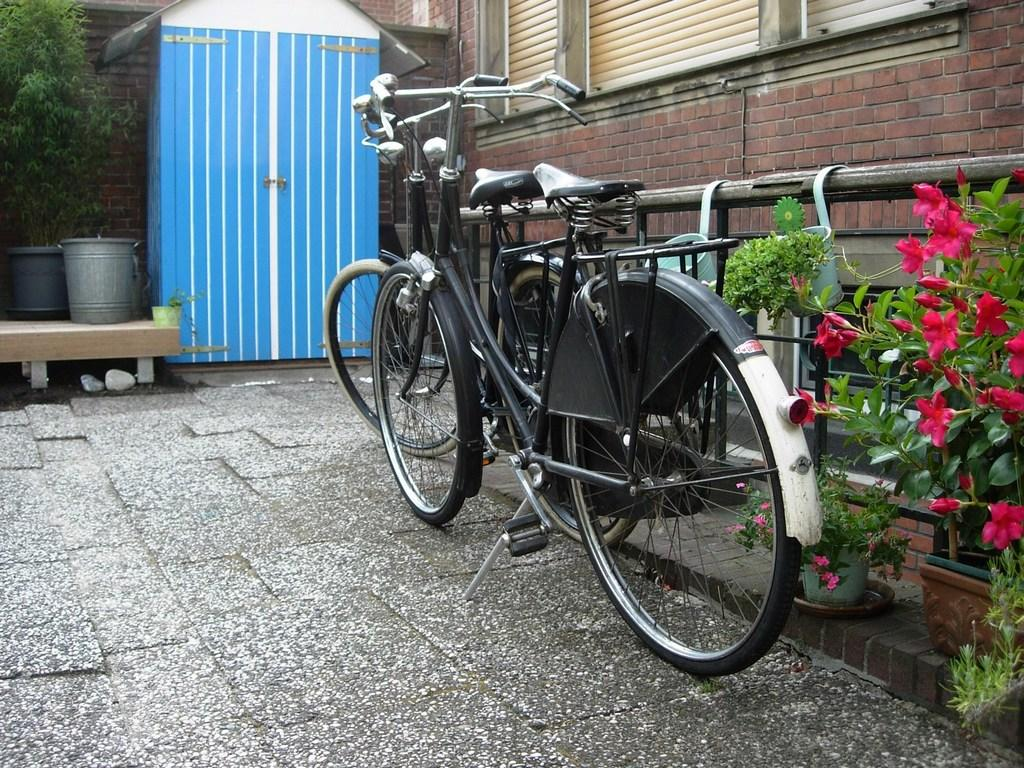What can be seen on the ground in the image? There are bicycles on the ground in the image. What type of plants are present in the image? There are house plants with flowers in the image. What is the background of the image made of? There is a wall in the image. Is there any opening in the wall? Yes, there is a window in the image. What type of structure is visible in the image? There is a shed in the image. What other natural element is present in the image? There is a tree in the image. Can you describe any other objects in the image? There are some unspecified objects in the image. What type of bird is perched on the wren in the image? There is no wren present in the image. What type of badge is being worn by the person in the image? There is no person or badge present in the image. What is the cause of the throat irritation in the image? There is no indication of throat irritation or any related issues in the image. 